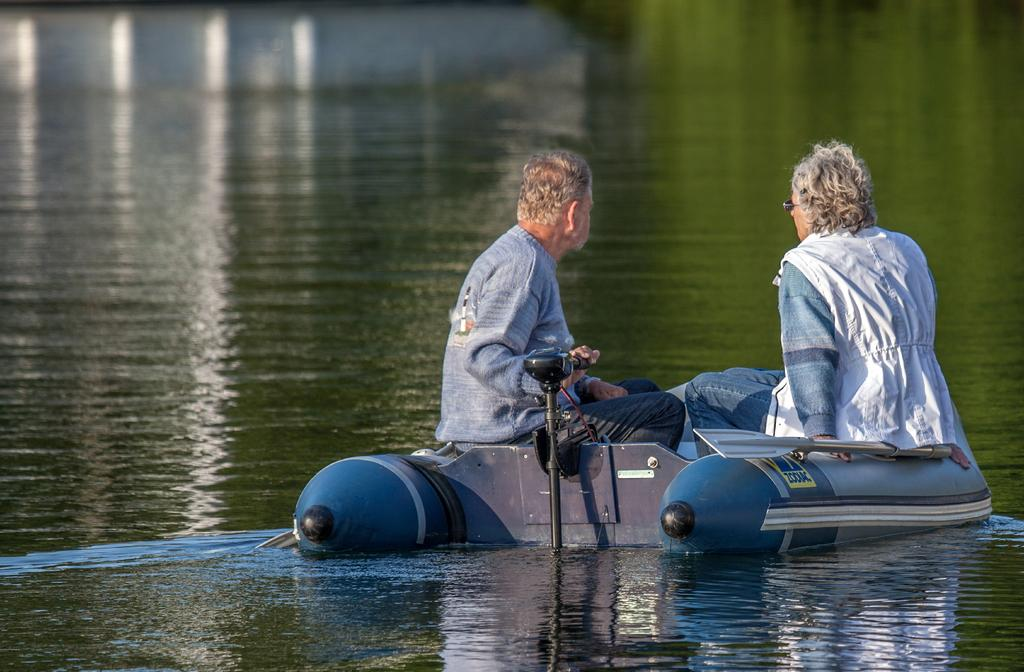Where was the picture taken? The picture was clicked outside the city. What are the two persons in the image doing? The two persons are sitting on a boat. What is the boat situated on? The boat is on a water body. What can be seen in the background of the image? There is a water body visible in the background of the image. What family member is missing from the boat in the image? There is no family member present in the image, as it only shows two persons sitting on a boat. What is the interest of the vein in the image? There is no vein present in the image, and therefore no interest can be attributed to it. 